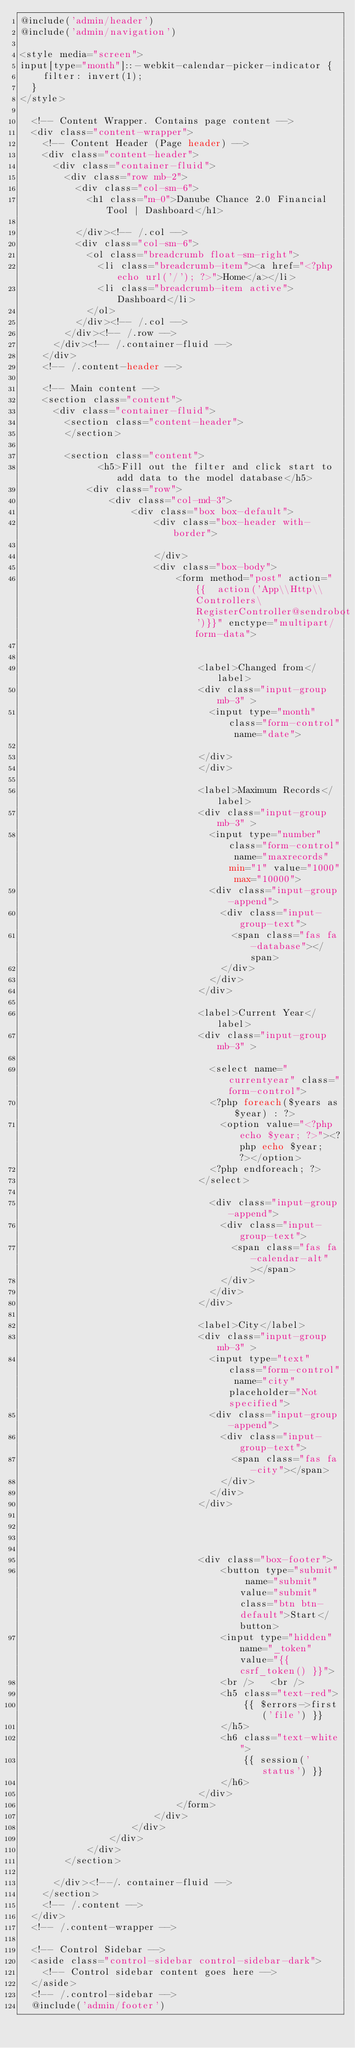Convert code to text. <code><loc_0><loc_0><loc_500><loc_500><_PHP_>@include('admin/header')
@include('admin/navigation')

<style media="screen">
input[type="month"]::-webkit-calendar-picker-indicator {
    filter: invert(1);
  }
</style>

  <!-- Content Wrapper. Contains page content -->
  <div class="content-wrapper">
    <!-- Content Header (Page header) -->
    <div class="content-header">
      <div class="container-fluid">
        <div class="row mb-2">
          <div class="col-sm-6">
            <h1 class="m-0">Danube Chance 2.0 Financial Tool | Dashboard</h1>

          </div><!-- /.col -->
          <div class="col-sm-6">
            <ol class="breadcrumb float-sm-right">
              <li class="breadcrumb-item"><a href="<?php echo url('/'); ?>">Home</a></li>
              <li class="breadcrumb-item active">Dashboard</li>
            </ol>
          </div><!-- /.col -->
        </div><!-- /.row -->
      </div><!-- /.container-fluid -->
    </div>
    <!-- /.content-header -->

    <!-- Main content -->
    <section class="content">
      <div class="container-fluid">
        <section class="content-header">
        </section>

        <section class="content">
              <h5>Fill out the filter and click start to add data to the model database</h5>
            <div class="row">
                <div class="col-md-3">
                    <div class="box box-default">
                        <div class="box-header with-border">

                        </div>
                        <div class="box-body">
                            <form method="post" action="{{  action('App\\Http\\Controllers\RegisterController@sendrobot')}}" enctype="multipart/form-data">


                                <label>Changed from</label>
                                <div class="input-group mb-3" >
                                  <input type="month" class="form-control" name="date">

                                </div>
                                </div>

                                <label>Maximum Records</label>
                                <div class="input-group mb-3" >
                                  <input type="number" class="form-control" name="maxrecords" min="1" value="1000" max="10000">
                                  <div class="input-group-append">
                                    <div class="input-group-text">
                                      <span class="fas fa-database"></span>
                                    </div>
                                  </div>
                                </div>

                                <label>Current Year</label>
                                <div class="input-group mb-3" >

                                  <select name="currentyear" class="form-control">
                                  <?php foreach($years as $year) : ?>
                                    <option value="<?php echo $year; ?>"><?php echo $year; ?></option>
                                  <?php endforeach; ?>
                                </select>

                                  <div class="input-group-append">
                                    <div class="input-group-text">
                                      <span class="fas fa-calendar-alt"></span>
                                    </div>
                                  </div>
                                </div>

                                <label>City</label>
                                <div class="input-group mb-3" >
                                  <input type="text" class="form-control" name="city" placeholder="Not specified">
                                  <div class="input-group-append">
                                    <div class="input-group-text">
                                      <span class="fas fa-city"></span>
                                    </div>
                                  </div>
                                </div>




                                <div class="box-footer">
                                    <button type="submit" name="submit" value="submit" class="btn btn-default">Start</button>
                                    <input type="hidden" name="_token" value="{{ csrf_token() }}">
                                    <br />   <br />
                                    <h5 class="text-red">
                                        {{ $errors->first('file') }}
                                    </h5>
                                    <h6 class="text-white">
                                        {{ session('status') }}
                                    </h6>
                                </div>
                            </form>
                        </div>
                    </div>
                </div>
            </div>
        </section>

      </div><!--/. container-fluid -->
    </section>
    <!-- /.content -->
  </div>
  <!-- /.content-wrapper -->

  <!-- Control Sidebar -->
  <aside class="control-sidebar control-sidebar-dark">
    <!-- Control sidebar content goes here -->
  </aside>
  <!-- /.control-sidebar -->
  @include('admin/footer')
</code> 